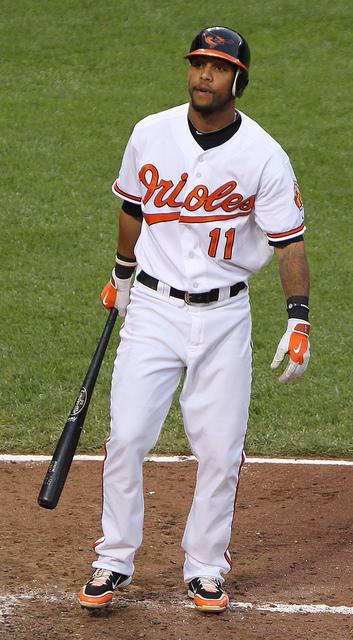What team does he play for?
Keep it brief. Orioles. What sport is this?
Be succinct. Baseball. How many times has the bat been swing during the ball game?
Concise answer only. 0. Is the man laying down?
Quick response, please. No. 